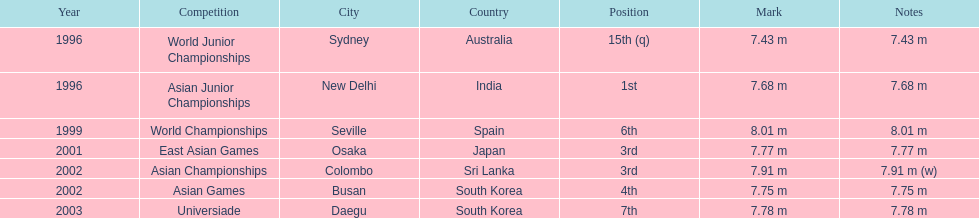Which competition did this person compete in immediately before the east asian games in 2001? World Championships. 